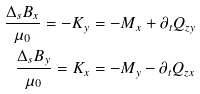Convert formula to latex. <formula><loc_0><loc_0><loc_500><loc_500>\frac { { \Delta } _ { s } { B } _ { x } } { { \mu } _ { 0 } } = { - K } _ { y } = - { M } _ { x } + { \partial } _ { t } { Q } _ { z y } \\ \frac { { \Delta } _ { s } { B } _ { y } } { { \mu } _ { 0 } } = { K } _ { x } = - { M } _ { y } - { \partial } _ { t } { Q } _ { z x }</formula> 